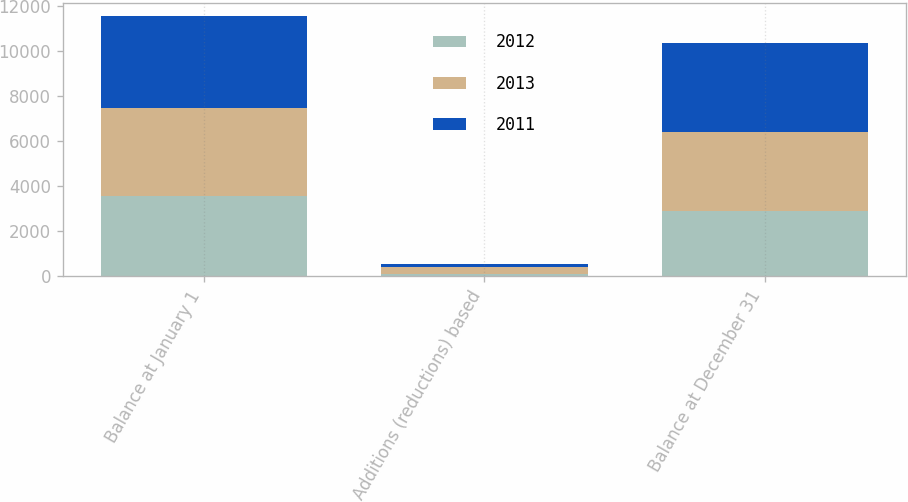<chart> <loc_0><loc_0><loc_500><loc_500><stacked_bar_chart><ecel><fcel>Balance at January 1<fcel>Additions (reductions) based<fcel>Balance at December 31<nl><fcel>2012<fcel>3536<fcel>99<fcel>2871<nl><fcel>2013<fcel>3917<fcel>303<fcel>3536<nl><fcel>2011<fcel>4071<fcel>154<fcel>3917<nl></chart> 